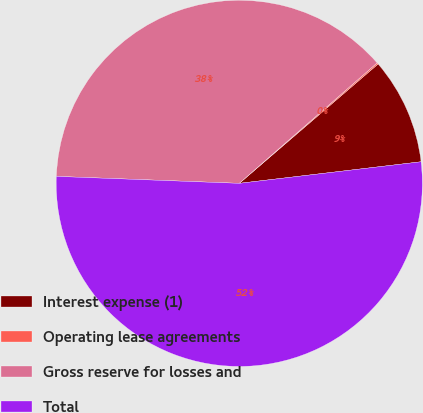<chart> <loc_0><loc_0><loc_500><loc_500><pie_chart><fcel>Interest expense (1)<fcel>Operating lease agreements<fcel>Gross reserve for losses and<fcel>Total<nl><fcel>9.42%<fcel>0.13%<fcel>37.96%<fcel>52.48%<nl></chart> 